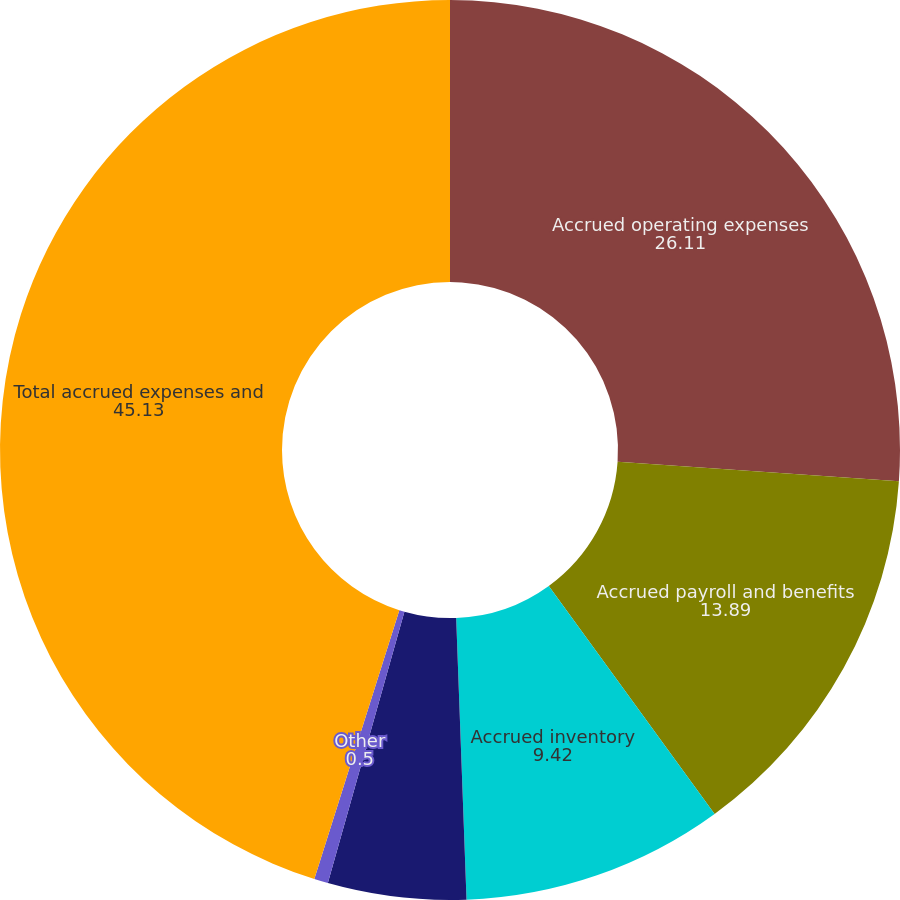Convert chart. <chart><loc_0><loc_0><loc_500><loc_500><pie_chart><fcel>Accrued operating expenses<fcel>Accrued payroll and benefits<fcel>Accrued inventory<fcel>Deferred income<fcel>Other<fcel>Total accrued expenses and<nl><fcel>26.11%<fcel>13.89%<fcel>9.42%<fcel>4.96%<fcel>0.5%<fcel>45.13%<nl></chart> 